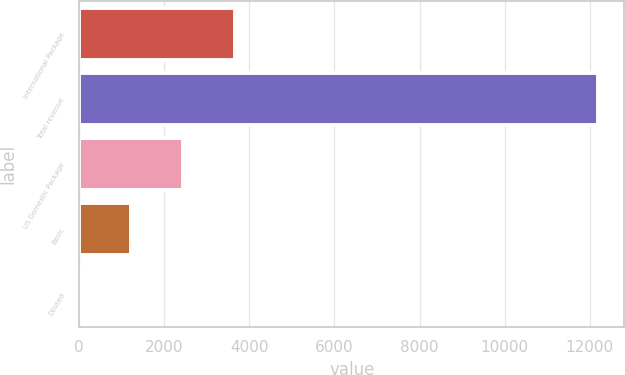Convert chart. <chart><loc_0><loc_0><loc_500><loc_500><bar_chart><fcel>International Package<fcel>Total revenue<fcel>US Domestic Package<fcel>Basic<fcel>Diluted<nl><fcel>3661.8<fcel>12204<fcel>2441.48<fcel>1221.16<fcel>0.84<nl></chart> 